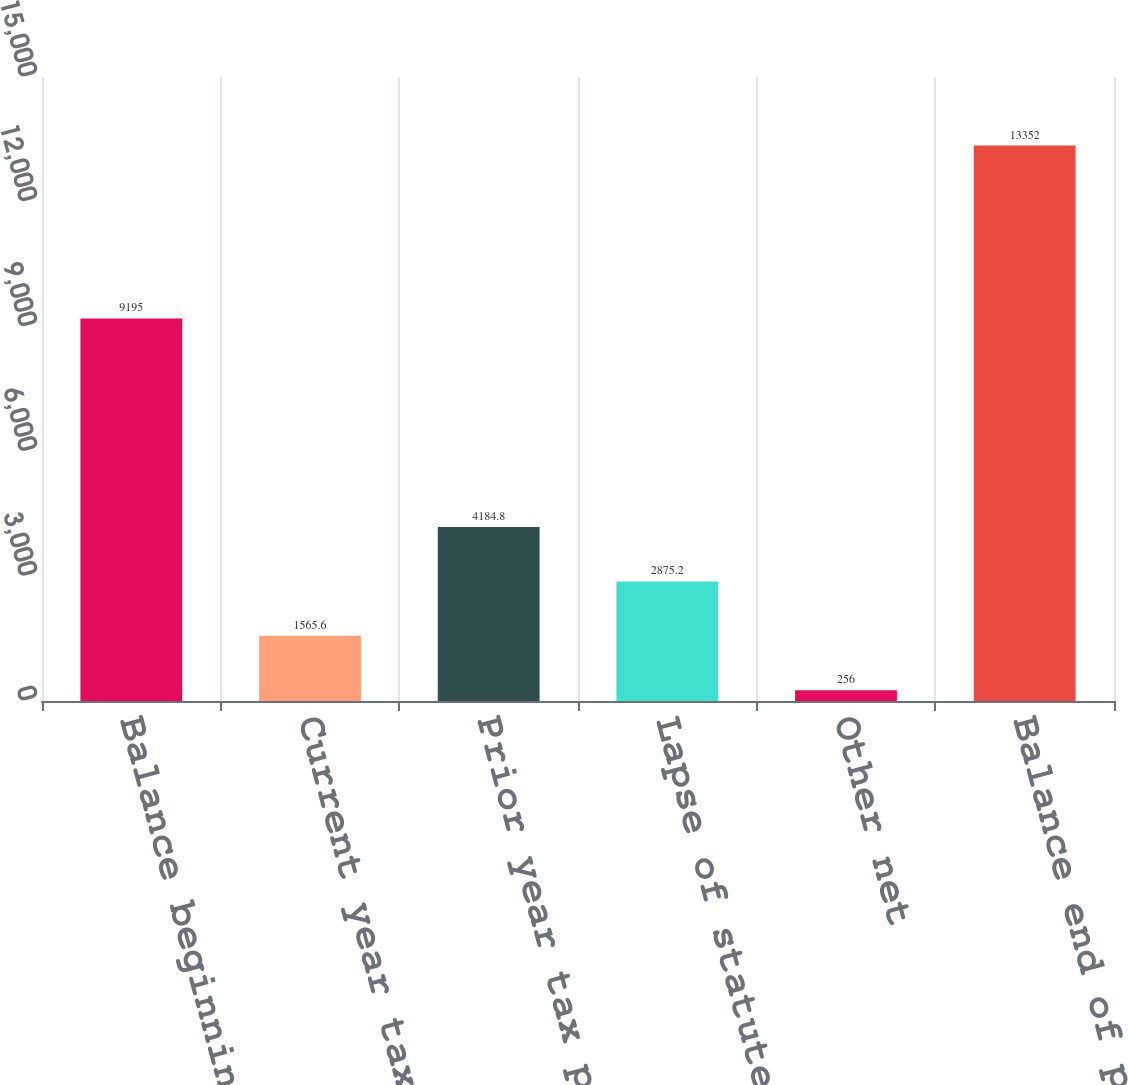Convert chart to OTSL. <chart><loc_0><loc_0><loc_500><loc_500><bar_chart><fcel>Balance beginning of period<fcel>Current year tax positions<fcel>Prior year tax positions<fcel>Lapse of statute of<fcel>Other net<fcel>Balance end of period<nl><fcel>9195<fcel>1565.6<fcel>4184.8<fcel>2875.2<fcel>256<fcel>13352<nl></chart> 